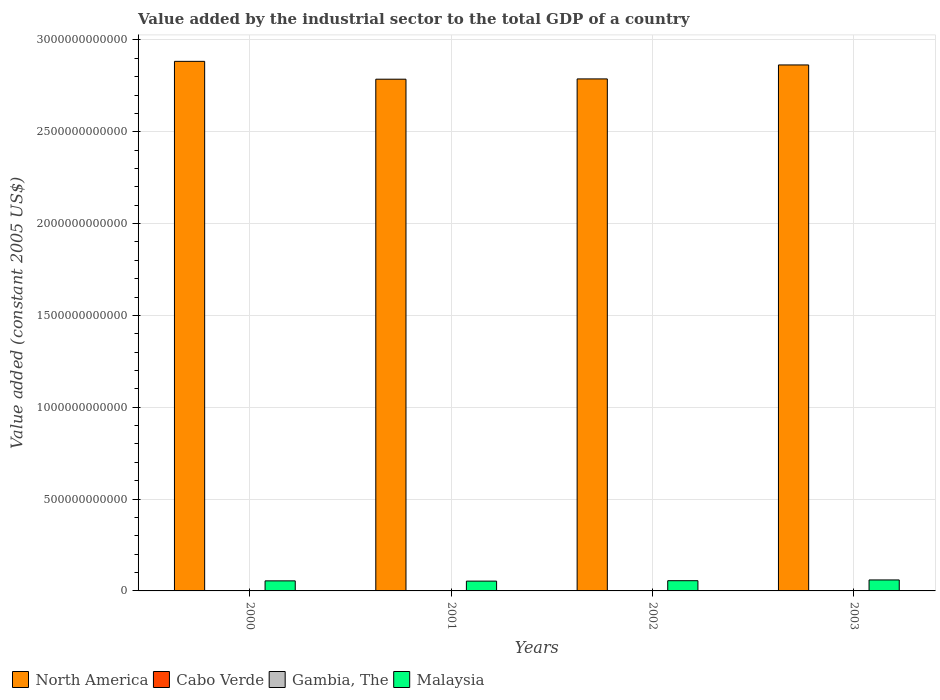How many groups of bars are there?
Your answer should be compact. 4. Are the number of bars per tick equal to the number of legend labels?
Your answer should be compact. Yes. How many bars are there on the 4th tick from the left?
Make the answer very short. 4. How many bars are there on the 1st tick from the right?
Your response must be concise. 4. What is the label of the 1st group of bars from the left?
Your answer should be very brief. 2000. What is the value added by the industrial sector in North America in 2002?
Ensure brevity in your answer.  2.79e+12. Across all years, what is the maximum value added by the industrial sector in Cabo Verde?
Make the answer very short. 1.60e+08. Across all years, what is the minimum value added by the industrial sector in Cabo Verde?
Provide a succinct answer. 1.46e+08. In which year was the value added by the industrial sector in Gambia, The minimum?
Your answer should be very brief. 2000. What is the total value added by the industrial sector in Malaysia in the graph?
Offer a very short reply. 2.24e+11. What is the difference between the value added by the industrial sector in Gambia, The in 2001 and that in 2002?
Provide a short and direct response. -8.08e+06. What is the difference between the value added by the industrial sector in North America in 2001 and the value added by the industrial sector in Malaysia in 2002?
Give a very brief answer. 2.73e+12. What is the average value added by the industrial sector in Cabo Verde per year?
Provide a succinct answer. 1.54e+08. In the year 2001, what is the difference between the value added by the industrial sector in Malaysia and value added by the industrial sector in Cabo Verde?
Your answer should be compact. 5.33e+1. What is the ratio of the value added by the industrial sector in Cabo Verde in 2001 to that in 2002?
Offer a very short reply. 0.94. Is the difference between the value added by the industrial sector in Malaysia in 2002 and 2003 greater than the difference between the value added by the industrial sector in Cabo Verde in 2002 and 2003?
Your response must be concise. No. What is the difference between the highest and the second highest value added by the industrial sector in Gambia, The?
Offer a very short reply. 2.06e+06. What is the difference between the highest and the lowest value added by the industrial sector in Gambia, The?
Your answer should be compact. 1.39e+07. In how many years, is the value added by the industrial sector in Cabo Verde greater than the average value added by the industrial sector in Cabo Verde taken over all years?
Ensure brevity in your answer.  3. Is the sum of the value added by the industrial sector in Cabo Verde in 2000 and 2002 greater than the maximum value added by the industrial sector in Gambia, The across all years?
Keep it short and to the point. Yes. What does the 3rd bar from the left in 2003 represents?
Keep it short and to the point. Gambia, The. What does the 3rd bar from the right in 2000 represents?
Your answer should be compact. Cabo Verde. Is it the case that in every year, the sum of the value added by the industrial sector in Gambia, The and value added by the industrial sector in North America is greater than the value added by the industrial sector in Cabo Verde?
Provide a succinct answer. Yes. What is the difference between two consecutive major ticks on the Y-axis?
Your response must be concise. 5.00e+11. Does the graph contain grids?
Provide a succinct answer. Yes. How many legend labels are there?
Ensure brevity in your answer.  4. What is the title of the graph?
Ensure brevity in your answer.  Value added by the industrial sector to the total GDP of a country. Does "Djibouti" appear as one of the legend labels in the graph?
Give a very brief answer. No. What is the label or title of the Y-axis?
Make the answer very short. Value added (constant 2005 US$). What is the Value added (constant 2005 US$) of North America in 2000?
Keep it short and to the point. 2.88e+12. What is the Value added (constant 2005 US$) of Cabo Verde in 2000?
Keep it short and to the point. 1.60e+08. What is the Value added (constant 2005 US$) in Gambia, The in 2000?
Your answer should be very brief. 6.91e+07. What is the Value added (constant 2005 US$) of Malaysia in 2000?
Ensure brevity in your answer.  5.48e+1. What is the Value added (constant 2005 US$) in North America in 2001?
Make the answer very short. 2.79e+12. What is the Value added (constant 2005 US$) in Cabo Verde in 2001?
Your answer should be compact. 1.46e+08. What is the Value added (constant 2005 US$) in Gambia, The in 2001?
Keep it short and to the point. 7.28e+07. What is the Value added (constant 2005 US$) in Malaysia in 2001?
Offer a very short reply. 5.34e+1. What is the Value added (constant 2005 US$) in North America in 2002?
Your response must be concise. 2.79e+12. What is the Value added (constant 2005 US$) of Cabo Verde in 2002?
Offer a very short reply. 1.55e+08. What is the Value added (constant 2005 US$) of Gambia, The in 2002?
Offer a terse response. 8.09e+07. What is the Value added (constant 2005 US$) of Malaysia in 2002?
Your answer should be compact. 5.56e+1. What is the Value added (constant 2005 US$) in North America in 2003?
Provide a short and direct response. 2.86e+12. What is the Value added (constant 2005 US$) of Cabo Verde in 2003?
Your answer should be compact. 1.57e+08. What is the Value added (constant 2005 US$) in Gambia, The in 2003?
Give a very brief answer. 8.30e+07. What is the Value added (constant 2005 US$) of Malaysia in 2003?
Keep it short and to the point. 5.97e+1. Across all years, what is the maximum Value added (constant 2005 US$) of North America?
Offer a very short reply. 2.88e+12. Across all years, what is the maximum Value added (constant 2005 US$) of Cabo Verde?
Your response must be concise. 1.60e+08. Across all years, what is the maximum Value added (constant 2005 US$) in Gambia, The?
Offer a terse response. 8.30e+07. Across all years, what is the maximum Value added (constant 2005 US$) of Malaysia?
Provide a succinct answer. 5.97e+1. Across all years, what is the minimum Value added (constant 2005 US$) of North America?
Your answer should be compact. 2.79e+12. Across all years, what is the minimum Value added (constant 2005 US$) in Cabo Verde?
Keep it short and to the point. 1.46e+08. Across all years, what is the minimum Value added (constant 2005 US$) of Gambia, The?
Your answer should be compact. 6.91e+07. Across all years, what is the minimum Value added (constant 2005 US$) of Malaysia?
Give a very brief answer. 5.34e+1. What is the total Value added (constant 2005 US$) of North America in the graph?
Your answer should be very brief. 1.13e+13. What is the total Value added (constant 2005 US$) in Cabo Verde in the graph?
Provide a succinct answer. 6.17e+08. What is the total Value added (constant 2005 US$) of Gambia, The in the graph?
Give a very brief answer. 3.06e+08. What is the total Value added (constant 2005 US$) in Malaysia in the graph?
Give a very brief answer. 2.24e+11. What is the difference between the Value added (constant 2005 US$) of North America in 2000 and that in 2001?
Ensure brevity in your answer.  9.72e+1. What is the difference between the Value added (constant 2005 US$) of Cabo Verde in 2000 and that in 2001?
Keep it short and to the point. 1.42e+07. What is the difference between the Value added (constant 2005 US$) of Gambia, The in 2000 and that in 2001?
Keep it short and to the point. -3.74e+06. What is the difference between the Value added (constant 2005 US$) in Malaysia in 2000 and that in 2001?
Keep it short and to the point. 1.37e+09. What is the difference between the Value added (constant 2005 US$) of North America in 2000 and that in 2002?
Give a very brief answer. 9.56e+1. What is the difference between the Value added (constant 2005 US$) of Cabo Verde in 2000 and that in 2002?
Ensure brevity in your answer.  5.37e+06. What is the difference between the Value added (constant 2005 US$) in Gambia, The in 2000 and that in 2002?
Ensure brevity in your answer.  -1.18e+07. What is the difference between the Value added (constant 2005 US$) of Malaysia in 2000 and that in 2002?
Your response must be concise. -8.67e+08. What is the difference between the Value added (constant 2005 US$) in North America in 2000 and that in 2003?
Provide a succinct answer. 1.95e+1. What is the difference between the Value added (constant 2005 US$) of Cabo Verde in 2000 and that in 2003?
Ensure brevity in your answer.  3.53e+06. What is the difference between the Value added (constant 2005 US$) of Gambia, The in 2000 and that in 2003?
Your answer should be very brief. -1.39e+07. What is the difference between the Value added (constant 2005 US$) of Malaysia in 2000 and that in 2003?
Make the answer very short. -4.98e+09. What is the difference between the Value added (constant 2005 US$) of North America in 2001 and that in 2002?
Keep it short and to the point. -1.61e+09. What is the difference between the Value added (constant 2005 US$) in Cabo Verde in 2001 and that in 2002?
Keep it short and to the point. -8.81e+06. What is the difference between the Value added (constant 2005 US$) in Gambia, The in 2001 and that in 2002?
Your response must be concise. -8.08e+06. What is the difference between the Value added (constant 2005 US$) of Malaysia in 2001 and that in 2002?
Make the answer very short. -2.24e+09. What is the difference between the Value added (constant 2005 US$) in North America in 2001 and that in 2003?
Offer a very short reply. -7.77e+1. What is the difference between the Value added (constant 2005 US$) of Cabo Verde in 2001 and that in 2003?
Offer a terse response. -1.06e+07. What is the difference between the Value added (constant 2005 US$) in Gambia, The in 2001 and that in 2003?
Provide a succinct answer. -1.01e+07. What is the difference between the Value added (constant 2005 US$) of Malaysia in 2001 and that in 2003?
Give a very brief answer. -6.35e+09. What is the difference between the Value added (constant 2005 US$) of North America in 2002 and that in 2003?
Offer a terse response. -7.61e+1. What is the difference between the Value added (constant 2005 US$) in Cabo Verde in 2002 and that in 2003?
Make the answer very short. -1.84e+06. What is the difference between the Value added (constant 2005 US$) in Gambia, The in 2002 and that in 2003?
Offer a very short reply. -2.06e+06. What is the difference between the Value added (constant 2005 US$) of Malaysia in 2002 and that in 2003?
Your answer should be compact. -4.11e+09. What is the difference between the Value added (constant 2005 US$) in North America in 2000 and the Value added (constant 2005 US$) in Cabo Verde in 2001?
Offer a terse response. 2.88e+12. What is the difference between the Value added (constant 2005 US$) in North America in 2000 and the Value added (constant 2005 US$) in Gambia, The in 2001?
Offer a terse response. 2.88e+12. What is the difference between the Value added (constant 2005 US$) of North America in 2000 and the Value added (constant 2005 US$) of Malaysia in 2001?
Give a very brief answer. 2.83e+12. What is the difference between the Value added (constant 2005 US$) in Cabo Verde in 2000 and the Value added (constant 2005 US$) in Gambia, The in 2001?
Offer a very short reply. 8.73e+07. What is the difference between the Value added (constant 2005 US$) in Cabo Verde in 2000 and the Value added (constant 2005 US$) in Malaysia in 2001?
Make the answer very short. -5.32e+1. What is the difference between the Value added (constant 2005 US$) in Gambia, The in 2000 and the Value added (constant 2005 US$) in Malaysia in 2001?
Your answer should be very brief. -5.33e+1. What is the difference between the Value added (constant 2005 US$) of North America in 2000 and the Value added (constant 2005 US$) of Cabo Verde in 2002?
Offer a very short reply. 2.88e+12. What is the difference between the Value added (constant 2005 US$) in North America in 2000 and the Value added (constant 2005 US$) in Gambia, The in 2002?
Make the answer very short. 2.88e+12. What is the difference between the Value added (constant 2005 US$) of North America in 2000 and the Value added (constant 2005 US$) of Malaysia in 2002?
Make the answer very short. 2.83e+12. What is the difference between the Value added (constant 2005 US$) of Cabo Verde in 2000 and the Value added (constant 2005 US$) of Gambia, The in 2002?
Provide a short and direct response. 7.92e+07. What is the difference between the Value added (constant 2005 US$) in Cabo Verde in 2000 and the Value added (constant 2005 US$) in Malaysia in 2002?
Your response must be concise. -5.55e+1. What is the difference between the Value added (constant 2005 US$) in Gambia, The in 2000 and the Value added (constant 2005 US$) in Malaysia in 2002?
Give a very brief answer. -5.56e+1. What is the difference between the Value added (constant 2005 US$) of North America in 2000 and the Value added (constant 2005 US$) of Cabo Verde in 2003?
Keep it short and to the point. 2.88e+12. What is the difference between the Value added (constant 2005 US$) of North America in 2000 and the Value added (constant 2005 US$) of Gambia, The in 2003?
Offer a terse response. 2.88e+12. What is the difference between the Value added (constant 2005 US$) of North America in 2000 and the Value added (constant 2005 US$) of Malaysia in 2003?
Provide a succinct answer. 2.82e+12. What is the difference between the Value added (constant 2005 US$) in Cabo Verde in 2000 and the Value added (constant 2005 US$) in Gambia, The in 2003?
Ensure brevity in your answer.  7.72e+07. What is the difference between the Value added (constant 2005 US$) of Cabo Verde in 2000 and the Value added (constant 2005 US$) of Malaysia in 2003?
Keep it short and to the point. -5.96e+1. What is the difference between the Value added (constant 2005 US$) in Gambia, The in 2000 and the Value added (constant 2005 US$) in Malaysia in 2003?
Keep it short and to the point. -5.97e+1. What is the difference between the Value added (constant 2005 US$) of North America in 2001 and the Value added (constant 2005 US$) of Cabo Verde in 2002?
Ensure brevity in your answer.  2.79e+12. What is the difference between the Value added (constant 2005 US$) of North America in 2001 and the Value added (constant 2005 US$) of Gambia, The in 2002?
Make the answer very short. 2.79e+12. What is the difference between the Value added (constant 2005 US$) in North America in 2001 and the Value added (constant 2005 US$) in Malaysia in 2002?
Your response must be concise. 2.73e+12. What is the difference between the Value added (constant 2005 US$) in Cabo Verde in 2001 and the Value added (constant 2005 US$) in Gambia, The in 2002?
Your answer should be compact. 6.50e+07. What is the difference between the Value added (constant 2005 US$) in Cabo Verde in 2001 and the Value added (constant 2005 US$) in Malaysia in 2002?
Your response must be concise. -5.55e+1. What is the difference between the Value added (constant 2005 US$) in Gambia, The in 2001 and the Value added (constant 2005 US$) in Malaysia in 2002?
Your response must be concise. -5.56e+1. What is the difference between the Value added (constant 2005 US$) of North America in 2001 and the Value added (constant 2005 US$) of Cabo Verde in 2003?
Give a very brief answer. 2.79e+12. What is the difference between the Value added (constant 2005 US$) in North America in 2001 and the Value added (constant 2005 US$) in Gambia, The in 2003?
Provide a succinct answer. 2.79e+12. What is the difference between the Value added (constant 2005 US$) of North America in 2001 and the Value added (constant 2005 US$) of Malaysia in 2003?
Your answer should be very brief. 2.73e+12. What is the difference between the Value added (constant 2005 US$) of Cabo Verde in 2001 and the Value added (constant 2005 US$) of Gambia, The in 2003?
Offer a terse response. 6.30e+07. What is the difference between the Value added (constant 2005 US$) of Cabo Verde in 2001 and the Value added (constant 2005 US$) of Malaysia in 2003?
Your answer should be very brief. -5.96e+1. What is the difference between the Value added (constant 2005 US$) in Gambia, The in 2001 and the Value added (constant 2005 US$) in Malaysia in 2003?
Ensure brevity in your answer.  -5.97e+1. What is the difference between the Value added (constant 2005 US$) in North America in 2002 and the Value added (constant 2005 US$) in Cabo Verde in 2003?
Your response must be concise. 2.79e+12. What is the difference between the Value added (constant 2005 US$) in North America in 2002 and the Value added (constant 2005 US$) in Gambia, The in 2003?
Give a very brief answer. 2.79e+12. What is the difference between the Value added (constant 2005 US$) in North America in 2002 and the Value added (constant 2005 US$) in Malaysia in 2003?
Your answer should be compact. 2.73e+12. What is the difference between the Value added (constant 2005 US$) of Cabo Verde in 2002 and the Value added (constant 2005 US$) of Gambia, The in 2003?
Your answer should be very brief. 7.18e+07. What is the difference between the Value added (constant 2005 US$) in Cabo Verde in 2002 and the Value added (constant 2005 US$) in Malaysia in 2003?
Make the answer very short. -5.96e+1. What is the difference between the Value added (constant 2005 US$) of Gambia, The in 2002 and the Value added (constant 2005 US$) of Malaysia in 2003?
Your answer should be very brief. -5.97e+1. What is the average Value added (constant 2005 US$) of North America per year?
Make the answer very short. 2.83e+12. What is the average Value added (constant 2005 US$) in Cabo Verde per year?
Offer a terse response. 1.54e+08. What is the average Value added (constant 2005 US$) of Gambia, The per year?
Offer a terse response. 7.64e+07. What is the average Value added (constant 2005 US$) of Malaysia per year?
Make the answer very short. 5.59e+1. In the year 2000, what is the difference between the Value added (constant 2005 US$) of North America and Value added (constant 2005 US$) of Cabo Verde?
Your answer should be compact. 2.88e+12. In the year 2000, what is the difference between the Value added (constant 2005 US$) of North America and Value added (constant 2005 US$) of Gambia, The?
Make the answer very short. 2.88e+12. In the year 2000, what is the difference between the Value added (constant 2005 US$) in North America and Value added (constant 2005 US$) in Malaysia?
Ensure brevity in your answer.  2.83e+12. In the year 2000, what is the difference between the Value added (constant 2005 US$) of Cabo Verde and Value added (constant 2005 US$) of Gambia, The?
Give a very brief answer. 9.10e+07. In the year 2000, what is the difference between the Value added (constant 2005 US$) of Cabo Verde and Value added (constant 2005 US$) of Malaysia?
Ensure brevity in your answer.  -5.46e+1. In the year 2000, what is the difference between the Value added (constant 2005 US$) of Gambia, The and Value added (constant 2005 US$) of Malaysia?
Keep it short and to the point. -5.47e+1. In the year 2001, what is the difference between the Value added (constant 2005 US$) of North America and Value added (constant 2005 US$) of Cabo Verde?
Your response must be concise. 2.79e+12. In the year 2001, what is the difference between the Value added (constant 2005 US$) in North America and Value added (constant 2005 US$) in Gambia, The?
Your response must be concise. 2.79e+12. In the year 2001, what is the difference between the Value added (constant 2005 US$) of North America and Value added (constant 2005 US$) of Malaysia?
Provide a short and direct response. 2.73e+12. In the year 2001, what is the difference between the Value added (constant 2005 US$) in Cabo Verde and Value added (constant 2005 US$) in Gambia, The?
Keep it short and to the point. 7.31e+07. In the year 2001, what is the difference between the Value added (constant 2005 US$) in Cabo Verde and Value added (constant 2005 US$) in Malaysia?
Your response must be concise. -5.33e+1. In the year 2001, what is the difference between the Value added (constant 2005 US$) of Gambia, The and Value added (constant 2005 US$) of Malaysia?
Make the answer very short. -5.33e+1. In the year 2002, what is the difference between the Value added (constant 2005 US$) in North America and Value added (constant 2005 US$) in Cabo Verde?
Your response must be concise. 2.79e+12. In the year 2002, what is the difference between the Value added (constant 2005 US$) in North America and Value added (constant 2005 US$) in Gambia, The?
Make the answer very short. 2.79e+12. In the year 2002, what is the difference between the Value added (constant 2005 US$) of North America and Value added (constant 2005 US$) of Malaysia?
Offer a very short reply. 2.73e+12. In the year 2002, what is the difference between the Value added (constant 2005 US$) in Cabo Verde and Value added (constant 2005 US$) in Gambia, The?
Your answer should be compact. 7.38e+07. In the year 2002, what is the difference between the Value added (constant 2005 US$) in Cabo Verde and Value added (constant 2005 US$) in Malaysia?
Your answer should be very brief. -5.55e+1. In the year 2002, what is the difference between the Value added (constant 2005 US$) of Gambia, The and Value added (constant 2005 US$) of Malaysia?
Ensure brevity in your answer.  -5.56e+1. In the year 2003, what is the difference between the Value added (constant 2005 US$) of North America and Value added (constant 2005 US$) of Cabo Verde?
Offer a terse response. 2.86e+12. In the year 2003, what is the difference between the Value added (constant 2005 US$) in North America and Value added (constant 2005 US$) in Gambia, The?
Make the answer very short. 2.86e+12. In the year 2003, what is the difference between the Value added (constant 2005 US$) in North America and Value added (constant 2005 US$) in Malaysia?
Make the answer very short. 2.80e+12. In the year 2003, what is the difference between the Value added (constant 2005 US$) of Cabo Verde and Value added (constant 2005 US$) of Gambia, The?
Your answer should be very brief. 7.36e+07. In the year 2003, what is the difference between the Value added (constant 2005 US$) in Cabo Verde and Value added (constant 2005 US$) in Malaysia?
Make the answer very short. -5.96e+1. In the year 2003, what is the difference between the Value added (constant 2005 US$) of Gambia, The and Value added (constant 2005 US$) of Malaysia?
Your response must be concise. -5.97e+1. What is the ratio of the Value added (constant 2005 US$) of North America in 2000 to that in 2001?
Provide a short and direct response. 1.03. What is the ratio of the Value added (constant 2005 US$) in Cabo Verde in 2000 to that in 2001?
Your answer should be compact. 1.1. What is the ratio of the Value added (constant 2005 US$) of Gambia, The in 2000 to that in 2001?
Provide a succinct answer. 0.95. What is the ratio of the Value added (constant 2005 US$) in Malaysia in 2000 to that in 2001?
Keep it short and to the point. 1.03. What is the ratio of the Value added (constant 2005 US$) in North America in 2000 to that in 2002?
Keep it short and to the point. 1.03. What is the ratio of the Value added (constant 2005 US$) in Cabo Verde in 2000 to that in 2002?
Your response must be concise. 1.03. What is the ratio of the Value added (constant 2005 US$) in Gambia, The in 2000 to that in 2002?
Make the answer very short. 0.85. What is the ratio of the Value added (constant 2005 US$) in Malaysia in 2000 to that in 2002?
Keep it short and to the point. 0.98. What is the ratio of the Value added (constant 2005 US$) of North America in 2000 to that in 2003?
Make the answer very short. 1.01. What is the ratio of the Value added (constant 2005 US$) in Cabo Verde in 2000 to that in 2003?
Your response must be concise. 1.02. What is the ratio of the Value added (constant 2005 US$) of Gambia, The in 2000 to that in 2003?
Provide a succinct answer. 0.83. What is the ratio of the Value added (constant 2005 US$) in Cabo Verde in 2001 to that in 2002?
Your answer should be compact. 0.94. What is the ratio of the Value added (constant 2005 US$) in Gambia, The in 2001 to that in 2002?
Offer a terse response. 0.9. What is the ratio of the Value added (constant 2005 US$) of Malaysia in 2001 to that in 2002?
Provide a short and direct response. 0.96. What is the ratio of the Value added (constant 2005 US$) of North America in 2001 to that in 2003?
Your answer should be very brief. 0.97. What is the ratio of the Value added (constant 2005 US$) in Cabo Verde in 2001 to that in 2003?
Your answer should be very brief. 0.93. What is the ratio of the Value added (constant 2005 US$) in Gambia, The in 2001 to that in 2003?
Give a very brief answer. 0.88. What is the ratio of the Value added (constant 2005 US$) in Malaysia in 2001 to that in 2003?
Ensure brevity in your answer.  0.89. What is the ratio of the Value added (constant 2005 US$) of North America in 2002 to that in 2003?
Make the answer very short. 0.97. What is the ratio of the Value added (constant 2005 US$) of Cabo Verde in 2002 to that in 2003?
Provide a short and direct response. 0.99. What is the ratio of the Value added (constant 2005 US$) in Gambia, The in 2002 to that in 2003?
Provide a succinct answer. 0.98. What is the ratio of the Value added (constant 2005 US$) in Malaysia in 2002 to that in 2003?
Make the answer very short. 0.93. What is the difference between the highest and the second highest Value added (constant 2005 US$) of North America?
Offer a very short reply. 1.95e+1. What is the difference between the highest and the second highest Value added (constant 2005 US$) in Cabo Verde?
Your answer should be very brief. 3.53e+06. What is the difference between the highest and the second highest Value added (constant 2005 US$) of Gambia, The?
Your response must be concise. 2.06e+06. What is the difference between the highest and the second highest Value added (constant 2005 US$) of Malaysia?
Keep it short and to the point. 4.11e+09. What is the difference between the highest and the lowest Value added (constant 2005 US$) of North America?
Your answer should be compact. 9.72e+1. What is the difference between the highest and the lowest Value added (constant 2005 US$) of Cabo Verde?
Your answer should be very brief. 1.42e+07. What is the difference between the highest and the lowest Value added (constant 2005 US$) of Gambia, The?
Provide a succinct answer. 1.39e+07. What is the difference between the highest and the lowest Value added (constant 2005 US$) of Malaysia?
Keep it short and to the point. 6.35e+09. 